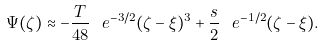Convert formula to latex. <formula><loc_0><loc_0><loc_500><loc_500>\Psi ( \zeta ) \approx - \frac { T } { 4 8 } \ e ^ { - 3 / 2 } ( \zeta - \xi ) ^ { 3 } + \frac { s } { 2 } \ e ^ { - 1 / 2 } ( \zeta - \xi ) .</formula> 